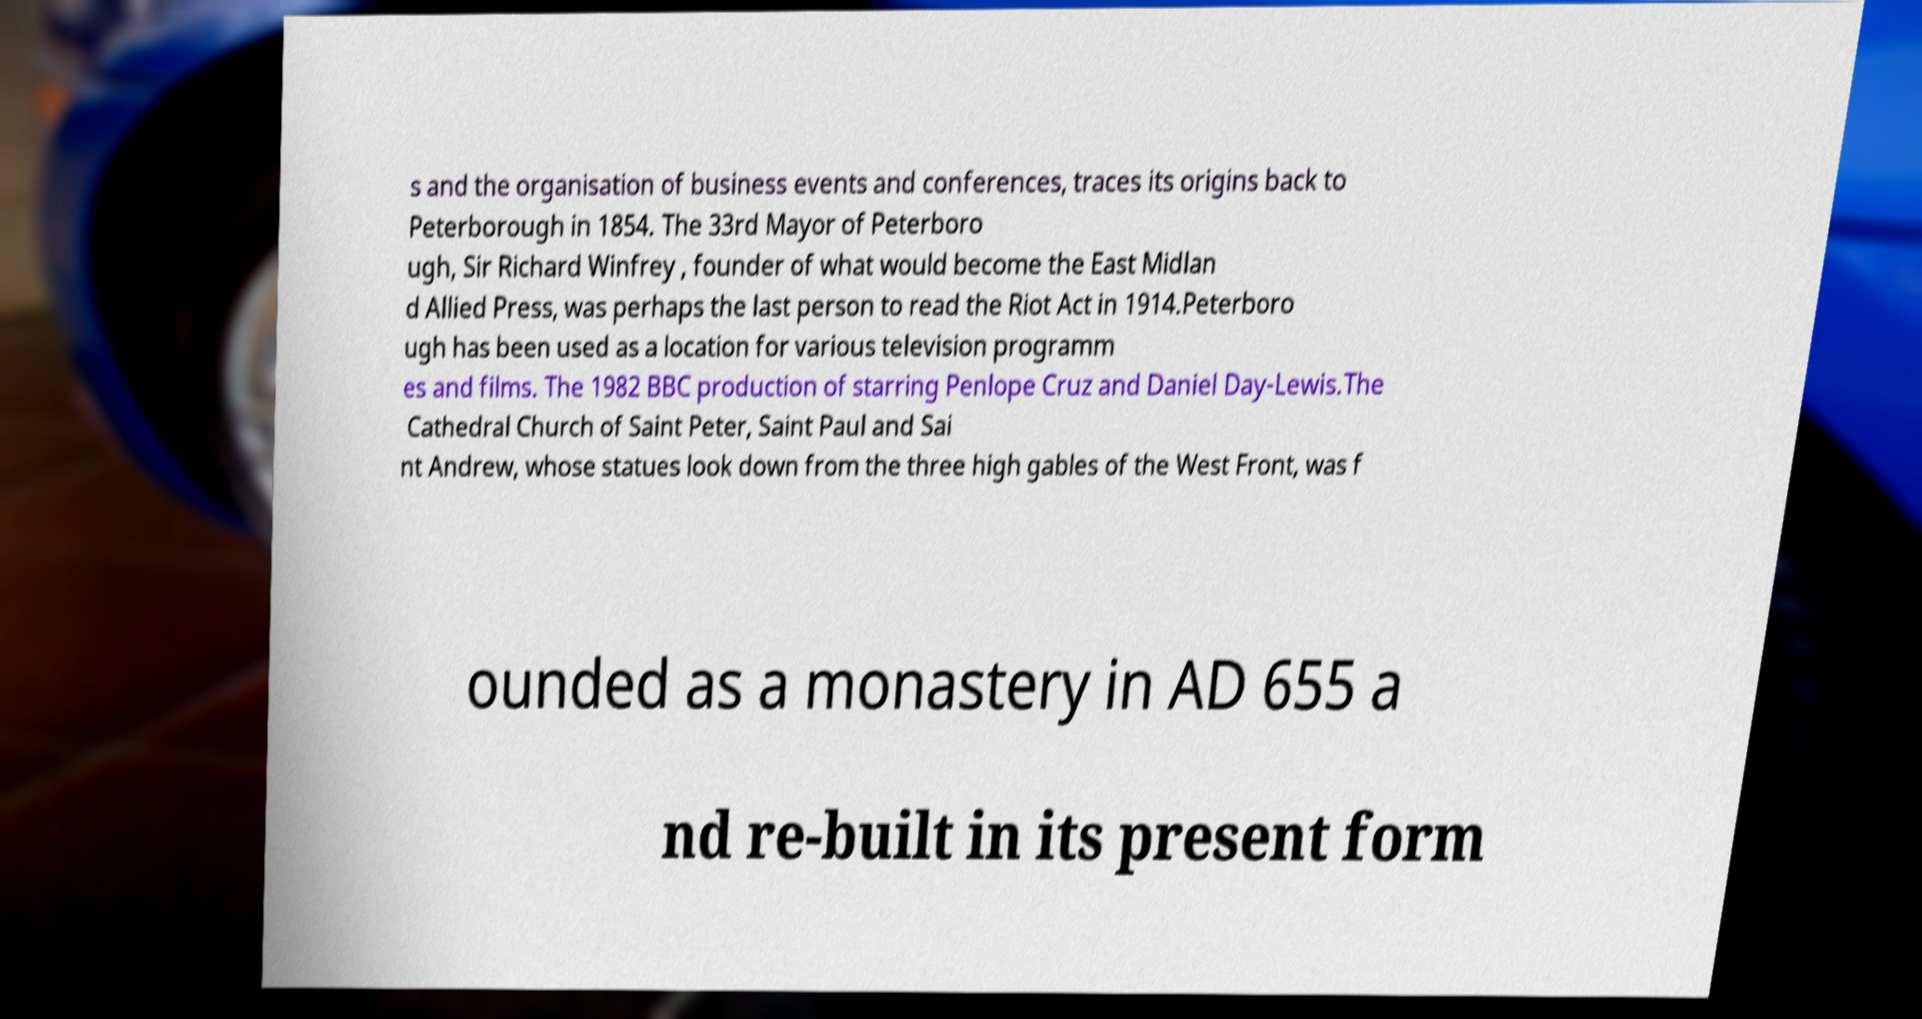I need the written content from this picture converted into text. Can you do that? s and the organisation of business events and conferences, traces its origins back to Peterborough in 1854. The 33rd Mayor of Peterboro ugh, Sir Richard Winfrey , founder of what would become the East Midlan d Allied Press, was perhaps the last person to read the Riot Act in 1914.Peterboro ugh has been used as a location for various television programm es and films. The 1982 BBC production of starring Penlope Cruz and Daniel Day-Lewis.The Cathedral Church of Saint Peter, Saint Paul and Sai nt Andrew, whose statues look down from the three high gables of the West Front, was f ounded as a monastery in AD 655 a nd re-built in its present form 